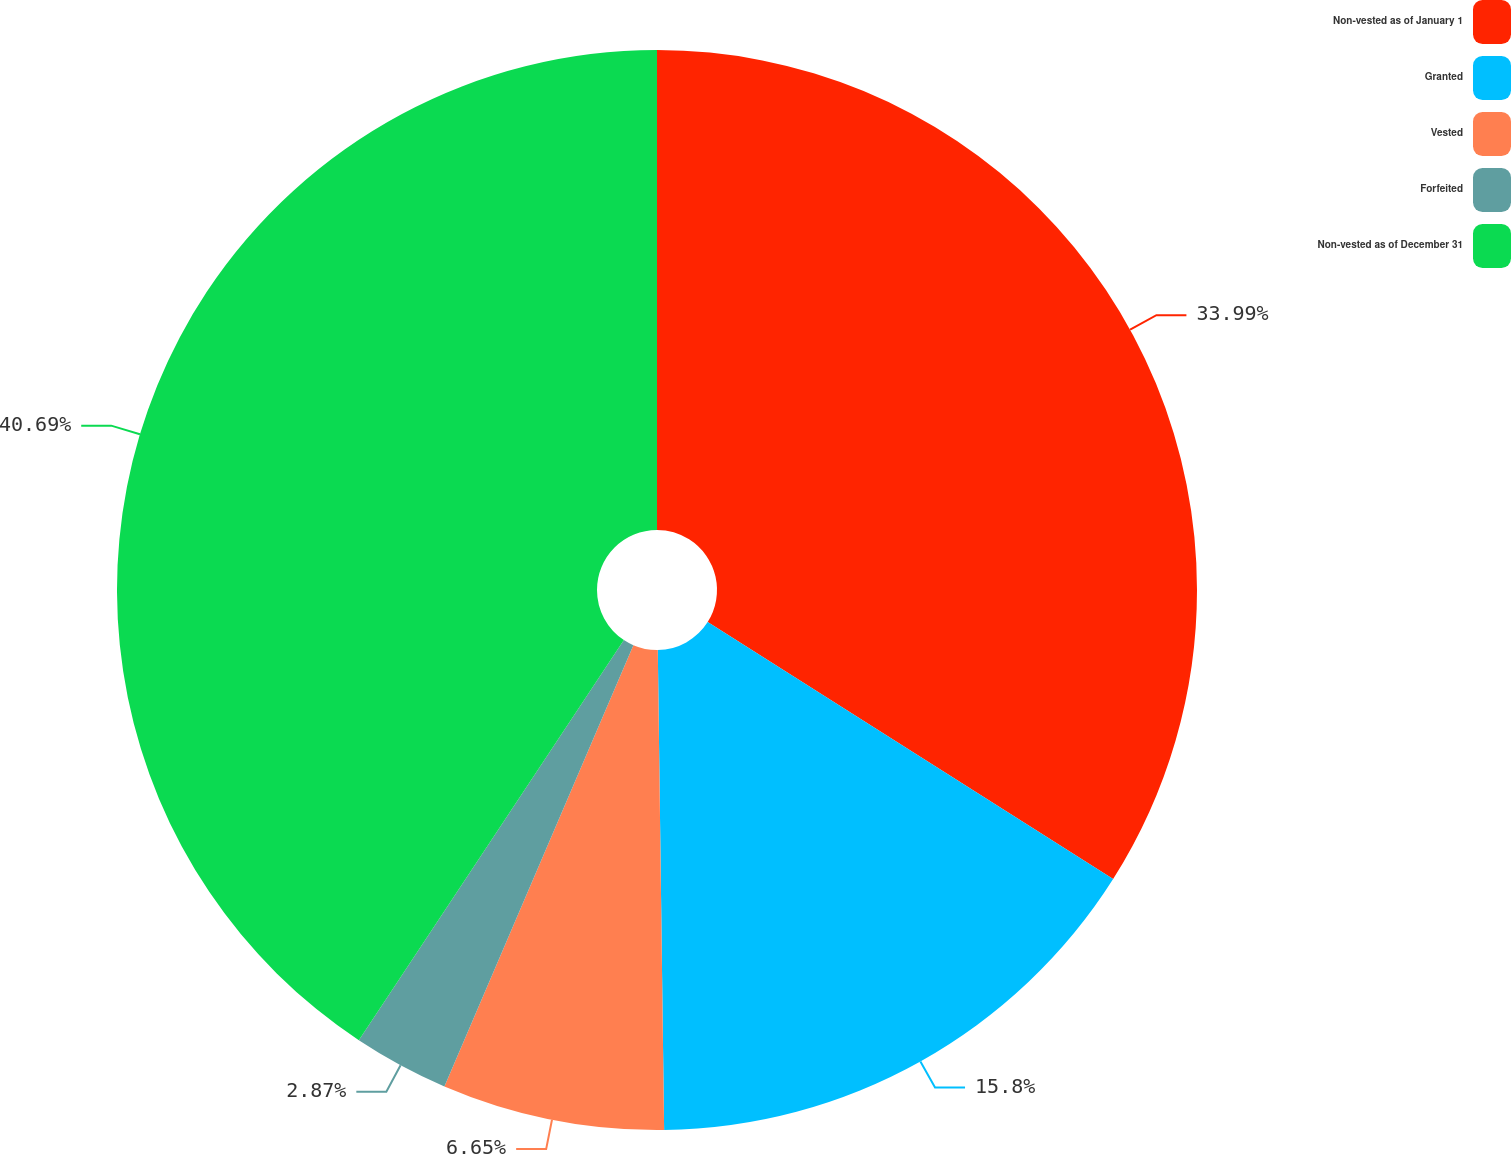Convert chart to OTSL. <chart><loc_0><loc_0><loc_500><loc_500><pie_chart><fcel>Non-vested as of January 1<fcel>Granted<fcel>Vested<fcel>Forfeited<fcel>Non-vested as of December 31<nl><fcel>33.99%<fcel>15.8%<fcel>6.65%<fcel>2.87%<fcel>40.69%<nl></chart> 